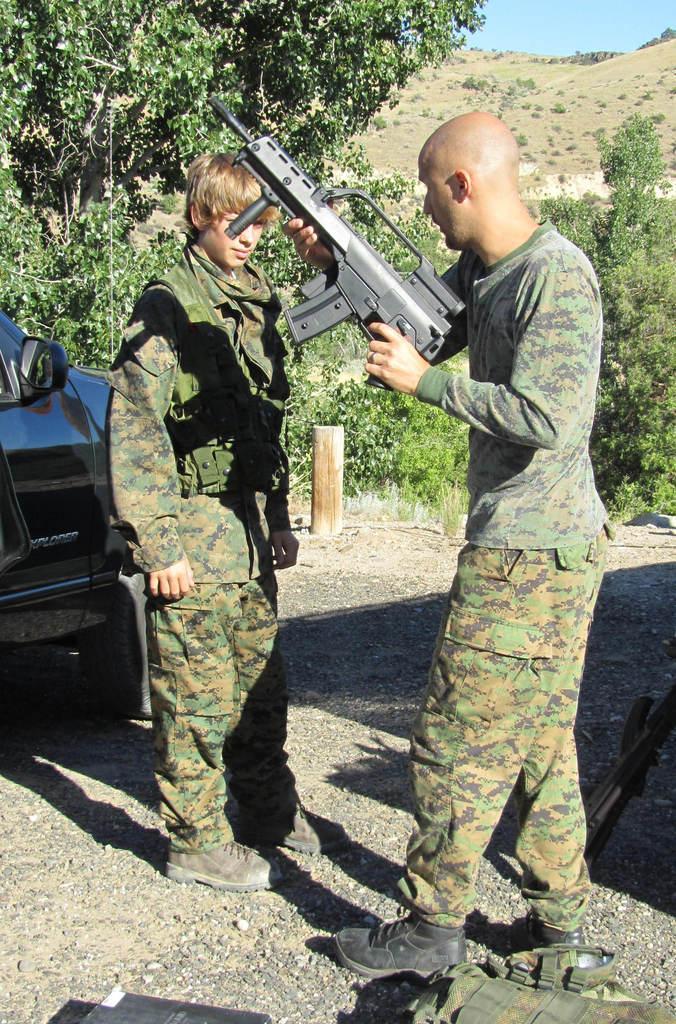Can you describe this image briefly? In the background we can see the sky and the thicket. In this picture we can see the trees, a man is holding a gun. Beside him we can see another person standing. On the left side of the picture we can see a vehicle and a small pole. On the ground we can see the few objects. 